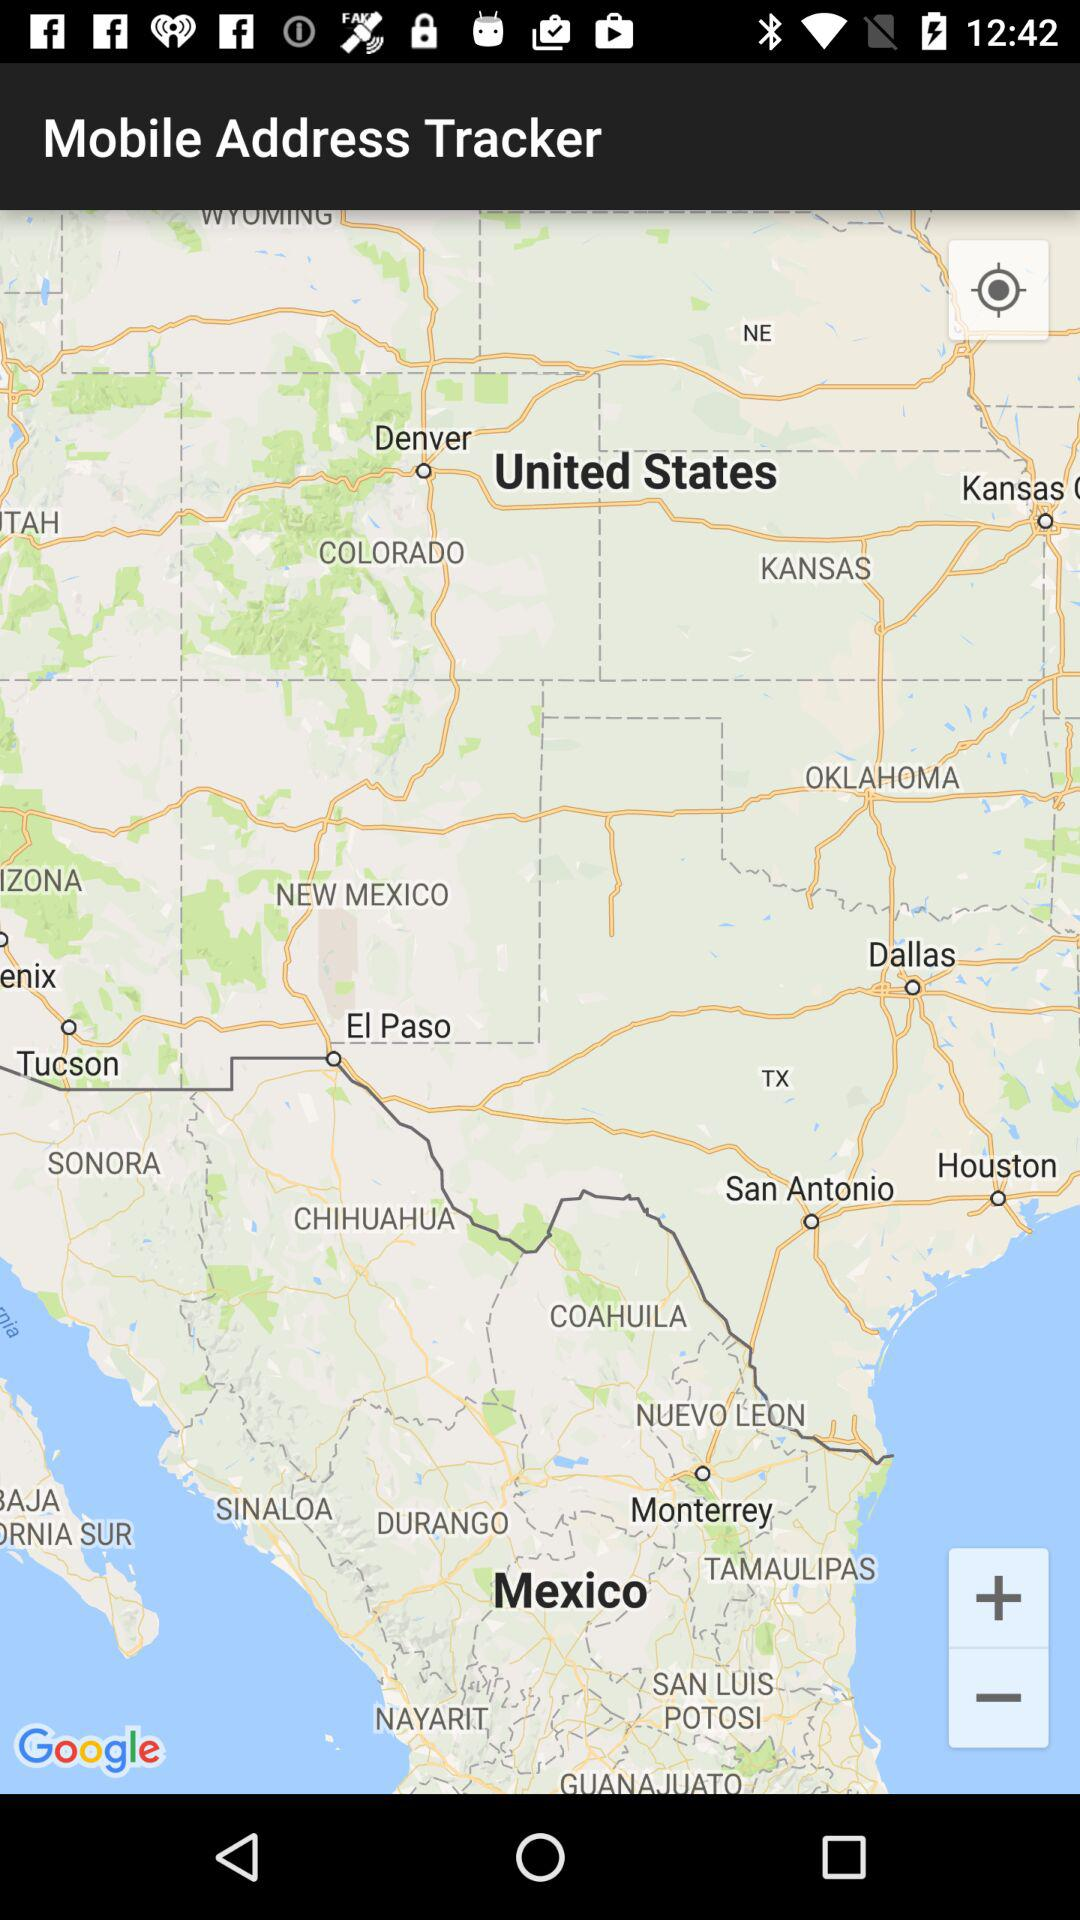What is the name of the application? The name of the application is "Mobile Address Tracker". 